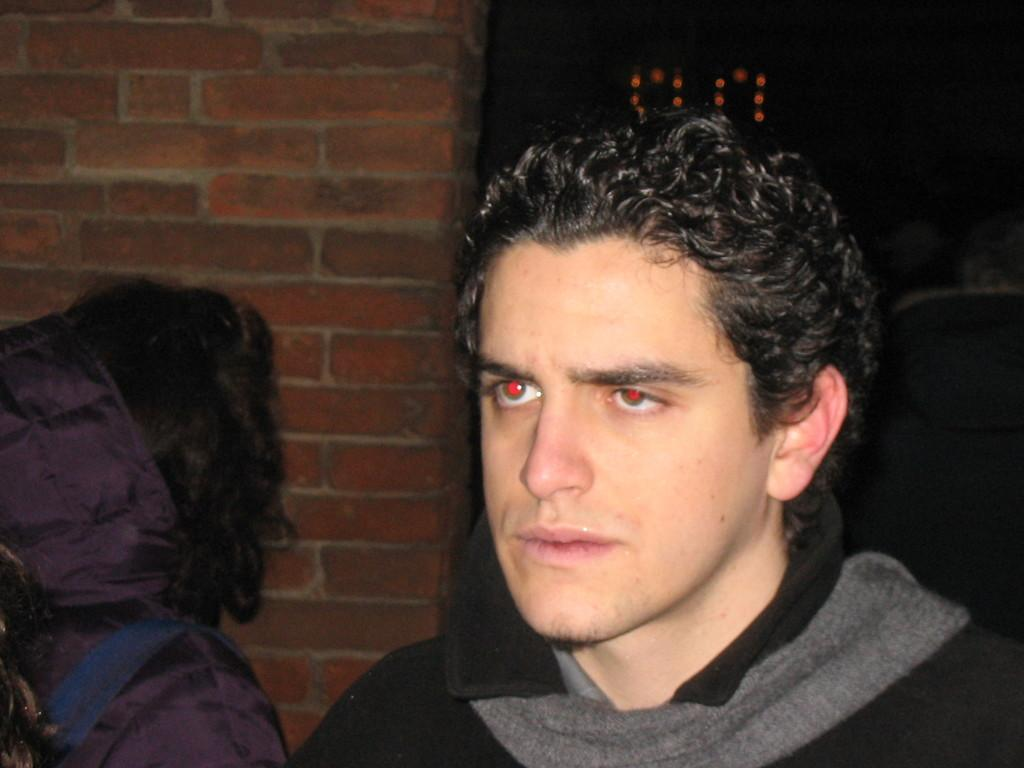Who or what is present in the image? There are people in the image. What can be seen in the background of the image? There is a wall and lights visible in the background of the image. What type of skirt is being worn by the people in the image? There is no mention of a skirt in the image, and it cannot be determined from the provided facts. 